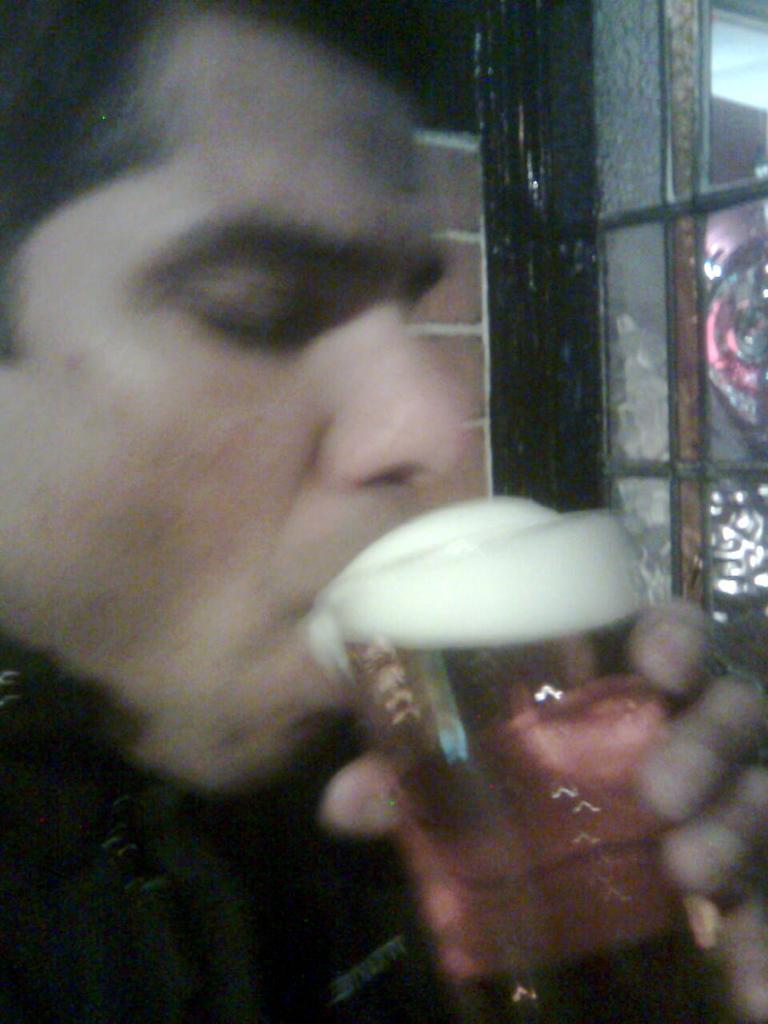Describe this image in one or two sentences. This picture describes a man is holding a glass in his hand, in the background we can see some glass door. 